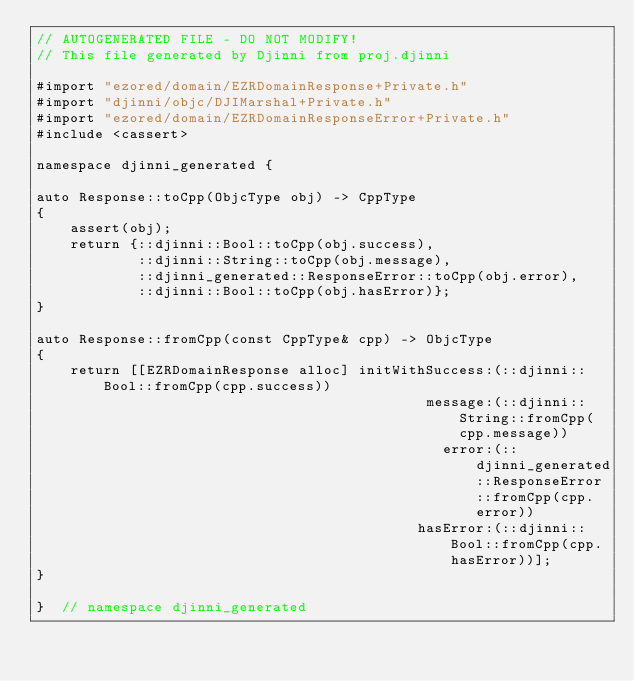<code> <loc_0><loc_0><loc_500><loc_500><_ObjectiveC_>// AUTOGENERATED FILE - DO NOT MODIFY!
// This file generated by Djinni from proj.djinni

#import "ezored/domain/EZRDomainResponse+Private.h"
#import "djinni/objc/DJIMarshal+Private.h"
#import "ezored/domain/EZRDomainResponseError+Private.h"
#include <cassert>

namespace djinni_generated {

auto Response::toCpp(ObjcType obj) -> CppType
{
    assert(obj);
    return {::djinni::Bool::toCpp(obj.success),
            ::djinni::String::toCpp(obj.message),
            ::djinni_generated::ResponseError::toCpp(obj.error),
            ::djinni::Bool::toCpp(obj.hasError)};
}

auto Response::fromCpp(const CppType& cpp) -> ObjcType
{
    return [[EZRDomainResponse alloc] initWithSuccess:(::djinni::Bool::fromCpp(cpp.success))
                                              message:(::djinni::String::fromCpp(cpp.message))
                                                error:(::djinni_generated::ResponseError::fromCpp(cpp.error))
                                             hasError:(::djinni::Bool::fromCpp(cpp.hasError))];
}

}  // namespace djinni_generated
</code> 